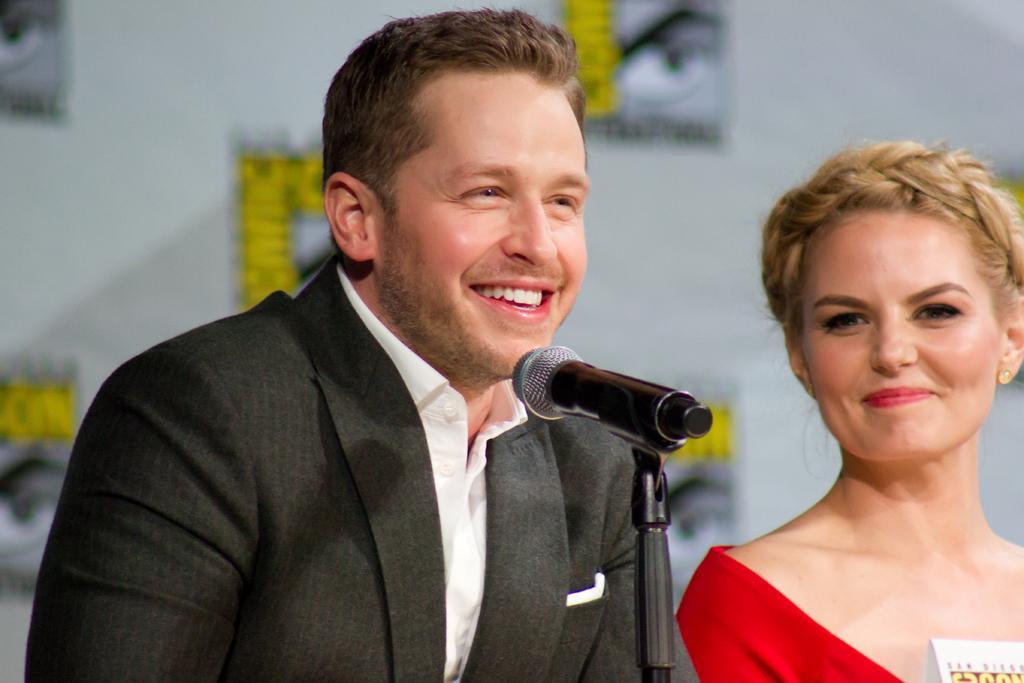Could you give a brief overview of what you see in this image? In this image there is a man and a woman. They are smiling. There is a microphone to its stand in front of the man. Behind them there is a wall. In the bottom right there is a board. 